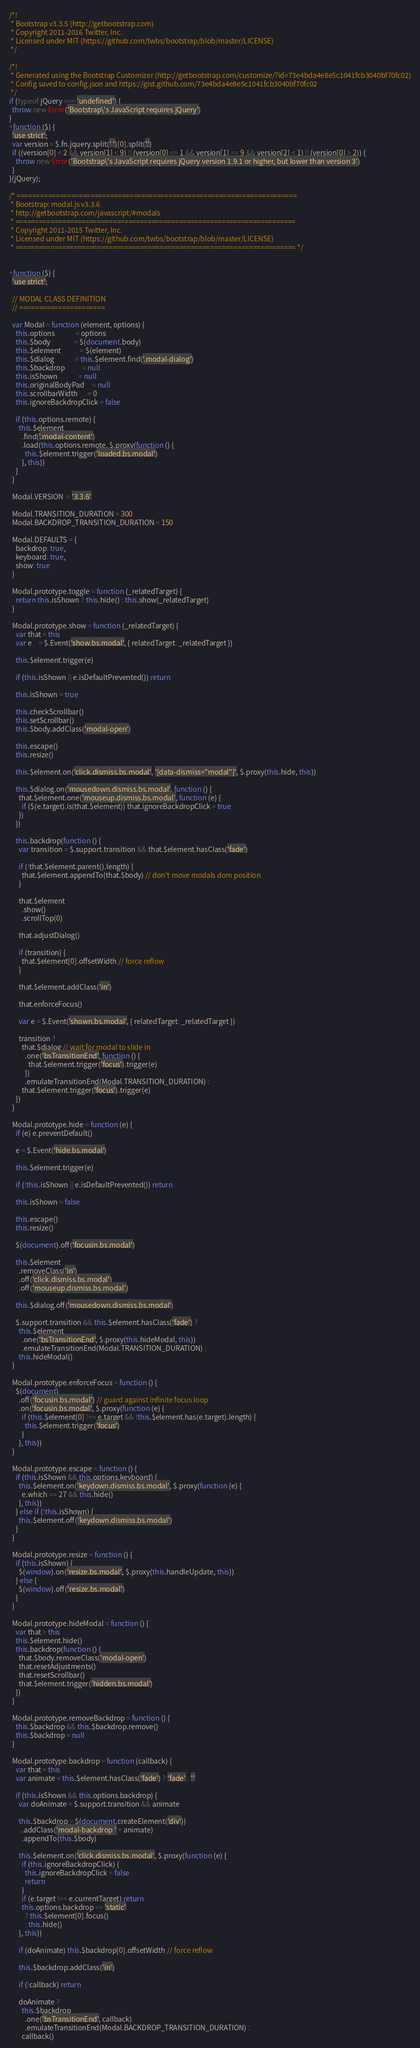<code> <loc_0><loc_0><loc_500><loc_500><_JavaScript_>/*!
 * Bootstrap v3.3.5 (http://getbootstrap.com)
 * Copyright 2011-2016 Twitter, Inc.
 * Licensed under MIT (https://github.com/twbs/bootstrap/blob/master/LICENSE)
 */

/*!
 * Generated using the Bootstrap Customizer (http://getbootstrap.com/customize/?id=73e4bda4e8e5c1041fcb3040bf70fc02)
 * Config saved to config.json and https://gist.github.com/73e4bda4e8e5c1041fcb3040bf70fc02
 */
if (typeof jQuery === 'undefined') {
  throw new Error('Bootstrap\'s JavaScript requires jQuery')
}
+function ($) {
  'use strict';
  var version = $.fn.jquery.split(' ')[0].split('.')
  if ((version[0] < 2 && version[1] < 9) || (version[0] == 1 && version[1] == 9 && version[2] < 1) || (version[0] > 2)) {
    throw new Error('Bootstrap\'s JavaScript requires jQuery version 1.9.1 or higher, but lower than version 3')
  }
}(jQuery);

/* ========================================================================
 * Bootstrap: modal.js v3.3.6
 * http://getbootstrap.com/javascript/#modals
 * ========================================================================
 * Copyright 2011-2015 Twitter, Inc.
 * Licensed under MIT (https://github.com/twbs/bootstrap/blob/master/LICENSE)
 * ======================================================================== */


+function ($) {
  'use strict';

  // MODAL CLASS DEFINITION
  // ======================

  var Modal = function (element, options) {
    this.options             = options
    this.$body               = $(document.body)
    this.$element            = $(element)
    this.$dialog             = this.$element.find('.modal-dialog')
    this.$backdrop           = null
    this.isShown             = null
    this.originalBodyPad     = null
    this.scrollbarWidth      = 0
    this.ignoreBackdropClick = false

    if (this.options.remote) {
      this.$element
        .find('.modal-content')
        .load(this.options.remote, $.proxy(function () {
          this.$element.trigger('loaded.bs.modal')
        }, this))
    }
  }

  Modal.VERSION  = '3.3.6'

  Modal.TRANSITION_DURATION = 300
  Modal.BACKDROP_TRANSITION_DURATION = 150

  Modal.DEFAULTS = {
    backdrop: true,
    keyboard: true,
    show: true
  }

  Modal.prototype.toggle = function (_relatedTarget) {
    return this.isShown ? this.hide() : this.show(_relatedTarget)
  }

  Modal.prototype.show = function (_relatedTarget) {
    var that = this
    var e    = $.Event('show.bs.modal', { relatedTarget: _relatedTarget })

    this.$element.trigger(e)

    if (this.isShown || e.isDefaultPrevented()) return

    this.isShown = true

    this.checkScrollbar()
    this.setScrollbar()
    this.$body.addClass('modal-open')

    this.escape()
    this.resize()

    this.$element.on('click.dismiss.bs.modal', '[data-dismiss="modal"]', $.proxy(this.hide, this))

    this.$dialog.on('mousedown.dismiss.bs.modal', function () {
      that.$element.one('mouseup.dismiss.bs.modal', function (e) {
        if ($(e.target).is(that.$element)) that.ignoreBackdropClick = true
      })
    })

    this.backdrop(function () {
      var transition = $.support.transition && that.$element.hasClass('fade')

      if (!that.$element.parent().length) {
        that.$element.appendTo(that.$body) // don't move modals dom position
      }

      that.$element
        .show()
        .scrollTop(0)

      that.adjustDialog()

      if (transition) {
        that.$element[0].offsetWidth // force reflow
      }

      that.$element.addClass('in')

      that.enforceFocus()

      var e = $.Event('shown.bs.modal', { relatedTarget: _relatedTarget })

      transition ?
        that.$dialog // wait for modal to slide in
          .one('bsTransitionEnd', function () {
            that.$element.trigger('focus').trigger(e)
          })
          .emulateTransitionEnd(Modal.TRANSITION_DURATION) :
        that.$element.trigger('focus').trigger(e)
    })
  }

  Modal.prototype.hide = function (e) {
    if (e) e.preventDefault()

    e = $.Event('hide.bs.modal')

    this.$element.trigger(e)

    if (!this.isShown || e.isDefaultPrevented()) return

    this.isShown = false

    this.escape()
    this.resize()

    $(document).off('focusin.bs.modal')

    this.$element
      .removeClass('in')
      .off('click.dismiss.bs.modal')
      .off('mouseup.dismiss.bs.modal')

    this.$dialog.off('mousedown.dismiss.bs.modal')

    $.support.transition && this.$element.hasClass('fade') ?
      this.$element
        .one('bsTransitionEnd', $.proxy(this.hideModal, this))
        .emulateTransitionEnd(Modal.TRANSITION_DURATION) :
      this.hideModal()
  }

  Modal.prototype.enforceFocus = function () {
    $(document)
      .off('focusin.bs.modal') // guard against infinite focus loop
      .on('focusin.bs.modal', $.proxy(function (e) {
        if (this.$element[0] !== e.target && !this.$element.has(e.target).length) {
          this.$element.trigger('focus')
        }
      }, this))
  }

  Modal.prototype.escape = function () {
    if (this.isShown && this.options.keyboard) {
      this.$element.on('keydown.dismiss.bs.modal', $.proxy(function (e) {
        e.which == 27 && this.hide()
      }, this))
    } else if (!this.isShown) {
      this.$element.off('keydown.dismiss.bs.modal')
    }
  }

  Modal.prototype.resize = function () {
    if (this.isShown) {
      $(window).on('resize.bs.modal', $.proxy(this.handleUpdate, this))
    } else {
      $(window).off('resize.bs.modal')
    }
  }

  Modal.prototype.hideModal = function () {
    var that = this
    this.$element.hide()
    this.backdrop(function () {
      that.$body.removeClass('modal-open')
      that.resetAdjustments()
      that.resetScrollbar()
      that.$element.trigger('hidden.bs.modal')
    })
  }

  Modal.prototype.removeBackdrop = function () {
    this.$backdrop && this.$backdrop.remove()
    this.$backdrop = null
  }

  Modal.prototype.backdrop = function (callback) {
    var that = this
    var animate = this.$element.hasClass('fade') ? 'fade' : ''

    if (this.isShown && this.options.backdrop) {
      var doAnimate = $.support.transition && animate

      this.$backdrop = $(document.createElement('div'))
        .addClass('modal-backdrop ' + animate)
        .appendTo(this.$body)

      this.$element.on('click.dismiss.bs.modal', $.proxy(function (e) {
        if (this.ignoreBackdropClick) {
          this.ignoreBackdropClick = false
          return
        }
        if (e.target !== e.currentTarget) return
        this.options.backdrop == 'static'
          ? this.$element[0].focus()
          : this.hide()
      }, this))

      if (doAnimate) this.$backdrop[0].offsetWidth // force reflow

      this.$backdrop.addClass('in')

      if (!callback) return

      doAnimate ?
        this.$backdrop
          .one('bsTransitionEnd', callback)
          .emulateTransitionEnd(Modal.BACKDROP_TRANSITION_DURATION) :
        callback()
</code> 